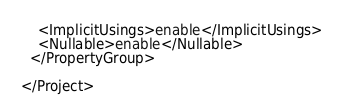<code> <loc_0><loc_0><loc_500><loc_500><_XML_>    <ImplicitUsings>enable</ImplicitUsings>
    <Nullable>enable</Nullable>
  </PropertyGroup>

</Project>
</code> 